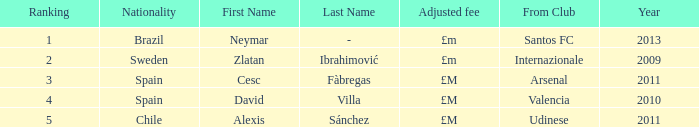What is the name of the player from Spain with a rank lower than 3? David Villa Category:Articles with hCards. 